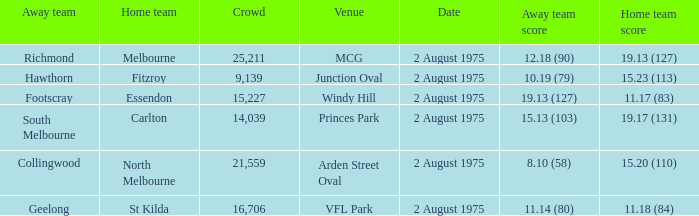What did the away team score when playing North Melbourne? 8.10 (58). 